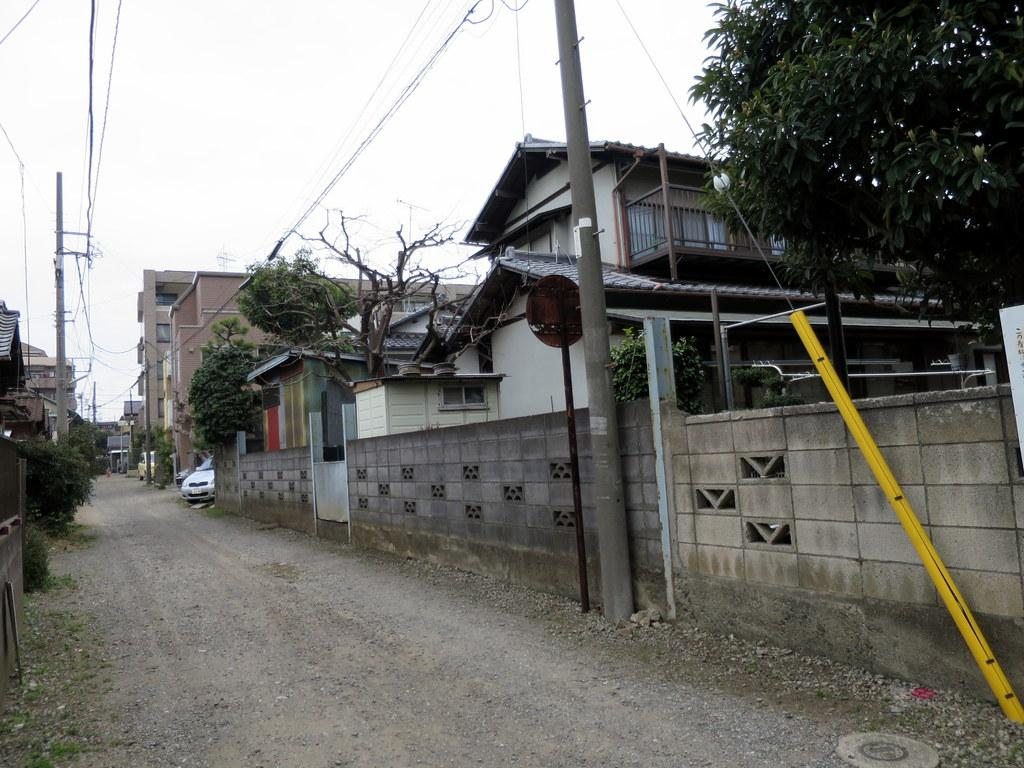What is the main feature of the image? There is a road in the image. What can be seen on both sides of the road? There are buildings on either side of the road. What type of vegetation is present in the image? There are trees in the image. What is visible above the buildings and trees? The sky is visible in the image. Where is the wilderness area in the image? There is no wilderness area present in the image; it features a road with buildings and trees. What type of mass can be seen lifting the buildings in the image? There is no mass lifting the buildings in the image; the buildings are standing on the ground. 